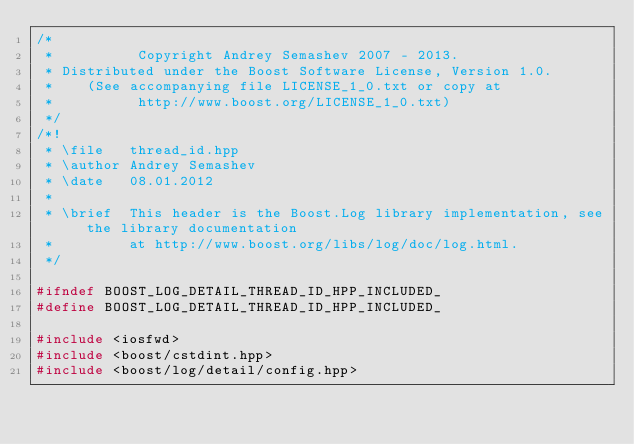<code> <loc_0><loc_0><loc_500><loc_500><_C++_>/*
 *          Copyright Andrey Semashev 2007 - 2013.
 * Distributed under the Boost Software License, Version 1.0.
 *    (See accompanying file LICENSE_1_0.txt or copy at
 *          http://www.boost.org/LICENSE_1_0.txt)
 */
/*!
 * \file   thread_id.hpp
 * \author Andrey Semashev
 * \date   08.01.2012
 *
 * \brief  This header is the Boost.Log library implementation, see the library documentation
 *         at http://www.boost.org/libs/log/doc/log.html.
 */

#ifndef BOOST_LOG_DETAIL_THREAD_ID_HPP_INCLUDED_
#define BOOST_LOG_DETAIL_THREAD_ID_HPP_INCLUDED_

#include <iosfwd>
#include <boost/cstdint.hpp>
#include <boost/log/detail/config.hpp></code> 